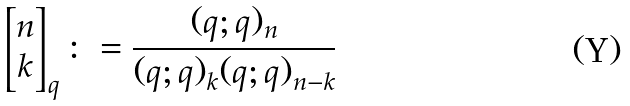Convert formula to latex. <formula><loc_0><loc_0><loc_500><loc_500>\left [ \begin{matrix} n \\ k \end{matrix} \right ] _ { q } \colon = \frac { ( q ; q ) _ { n } } { ( q ; q ) _ { k } ( q ; q ) _ { n - k } }</formula> 